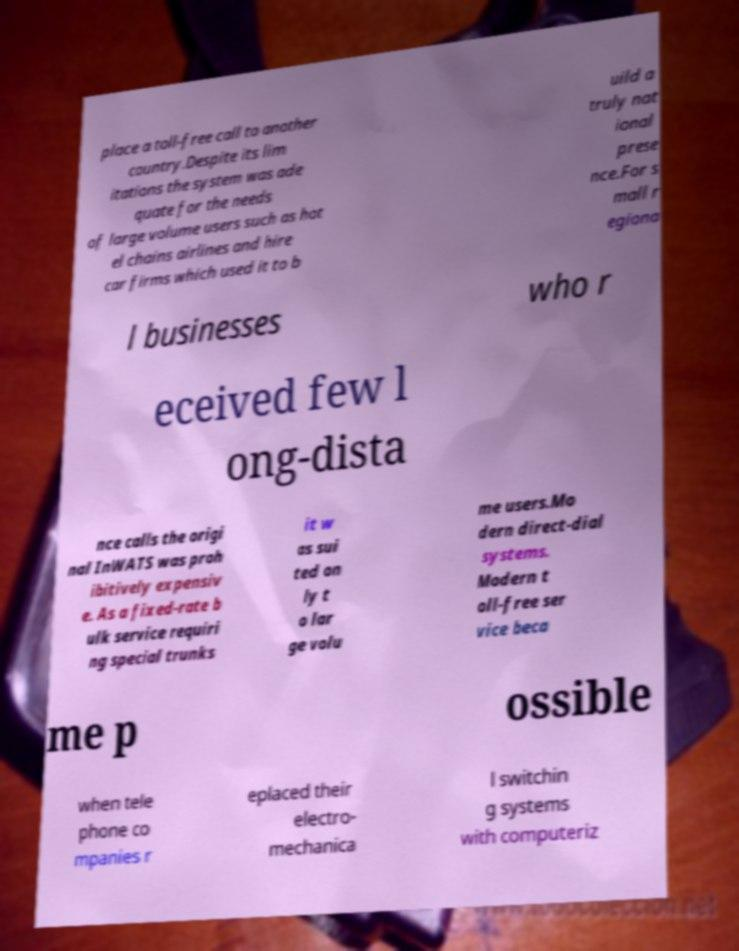For documentation purposes, I need the text within this image transcribed. Could you provide that? place a toll-free call to another country.Despite its lim itations the system was ade quate for the needs of large volume users such as hot el chains airlines and hire car firms which used it to b uild a truly nat ional prese nce.For s mall r egiona l businesses who r eceived few l ong-dista nce calls the origi nal InWATS was proh ibitively expensiv e. As a fixed-rate b ulk service requiri ng special trunks it w as sui ted on ly t o lar ge volu me users.Mo dern direct-dial systems. Modern t oll-free ser vice beca me p ossible when tele phone co mpanies r eplaced their electro- mechanica l switchin g systems with computeriz 